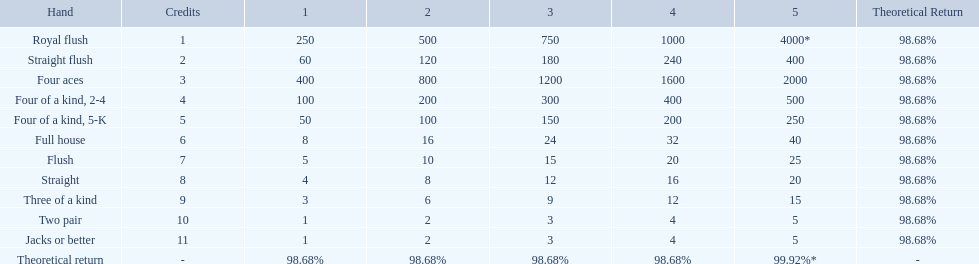What is the higher amount of points for one credit you can get from the best four of a kind 100. What type is it? Four of a kind, 2-4. 